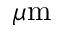Convert formula to latex. <formula><loc_0><loc_0><loc_500><loc_500>\mu m</formula> 